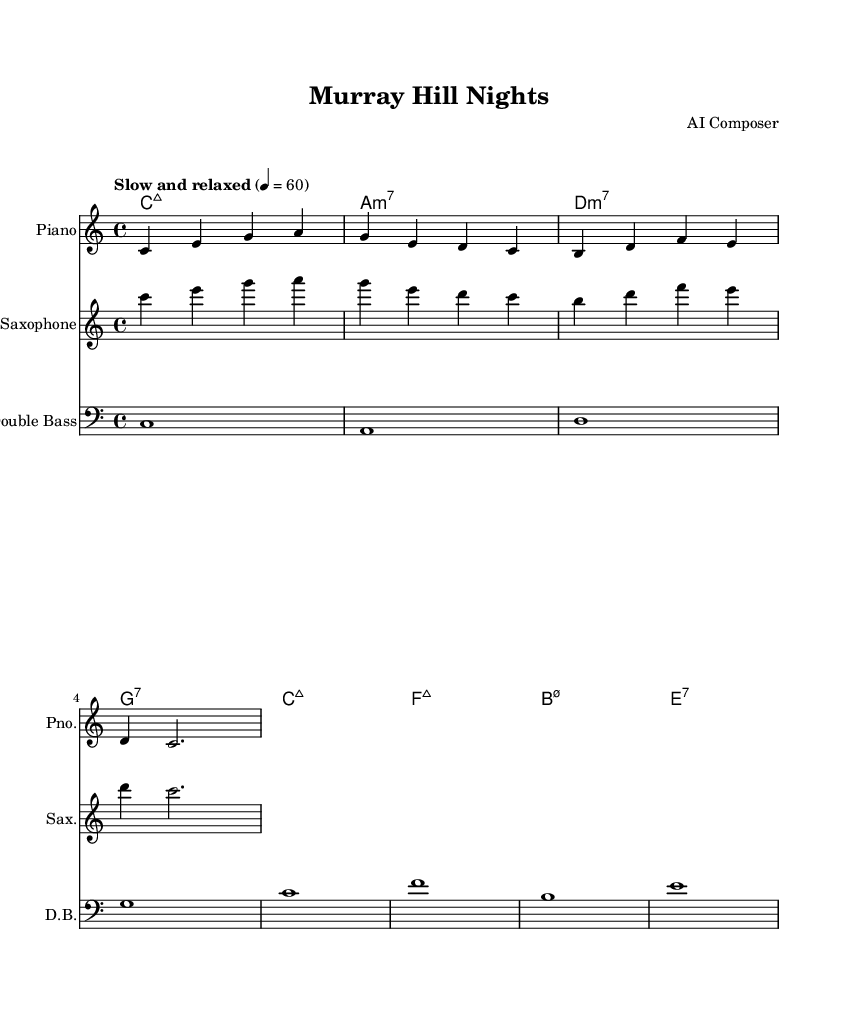What is the key signature of this music? The key signature is found at the beginning of the staff, indicating that the piece is in C major, which has no sharps or flats.
Answer: C major What is the time signature of this piece? The time signature is indicated right after the key signature, showing that the piece has a time signature of 4/4, meaning four beats per measure.
Answer: 4/4 What is the tempo marking given for the music? The tempo marking is found near the beginning of the score, indicating it should be played "Slow and relaxed" at a speed of quarter note equals 60 beats per minute.
Answer: Slow and relaxed How many measures are there in the piano part? By counting the vertical lines (bars) on the piano staff, we see there are five measures indicated in the excerpt provided.
Answer: Five What is the last chord in the piece? The last chord can be identified by looking at the chord names at the beginning of each bar; the last chord is an E dominant seventh chord.
Answer: E7 Which instrument has the highest pitch in this piece? Comparing the ranges of the instruments in the score, the saxophone plays in a higher pitch range than the piano or the double bass, making it the highest instrument in the ensemble.
Answer: Saxophone What type of jazz is this piece intended for? The setting and instrumentation, along with the relaxed tempo and chord choices, suggest the piece is designed as a relaxing instrumental jazz, perfect for retirement evenings in the city.
Answer: Relaxing instrumental jazz 